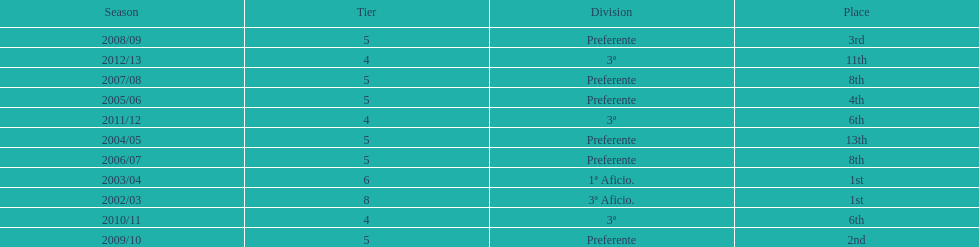How many times did internacional de madrid cf end the season at the top of their division? 2. 